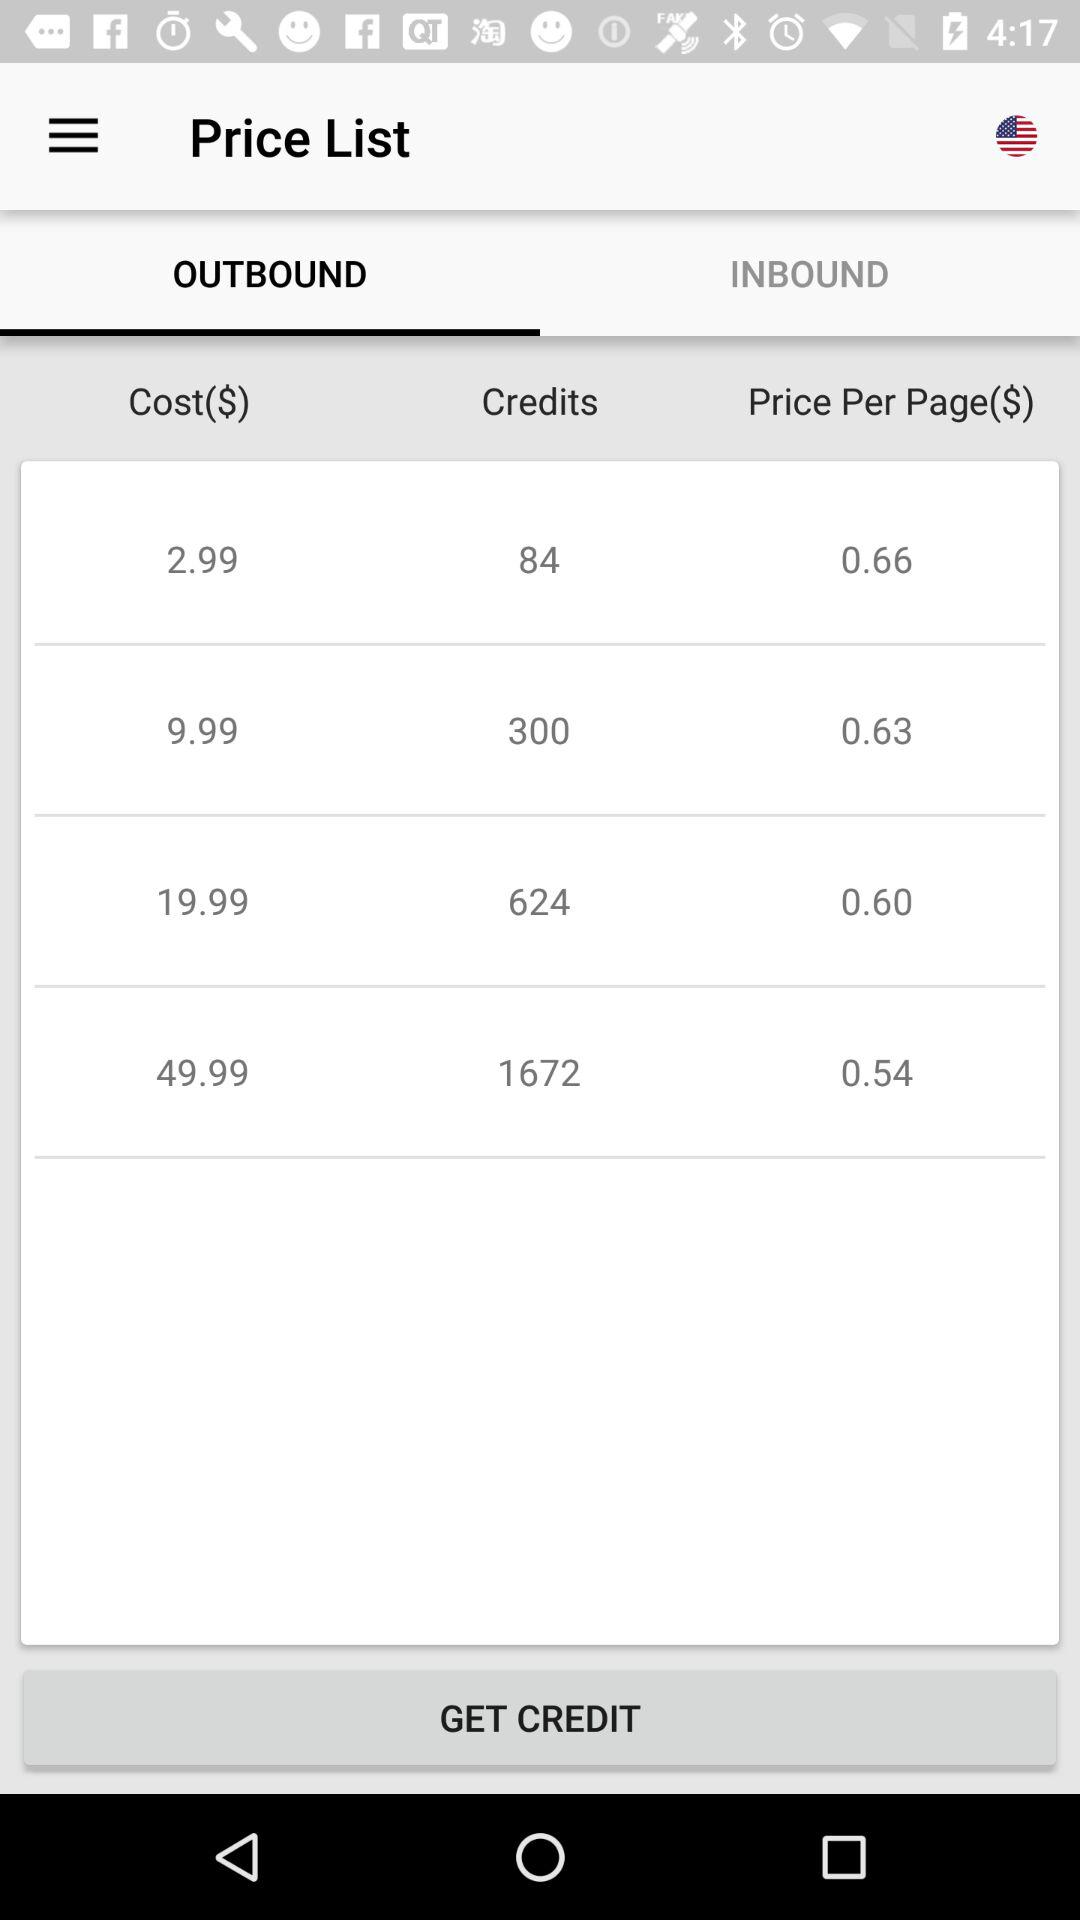How much does it price per page of 624 credits? The cost per page of 624 credits is $0.60. 